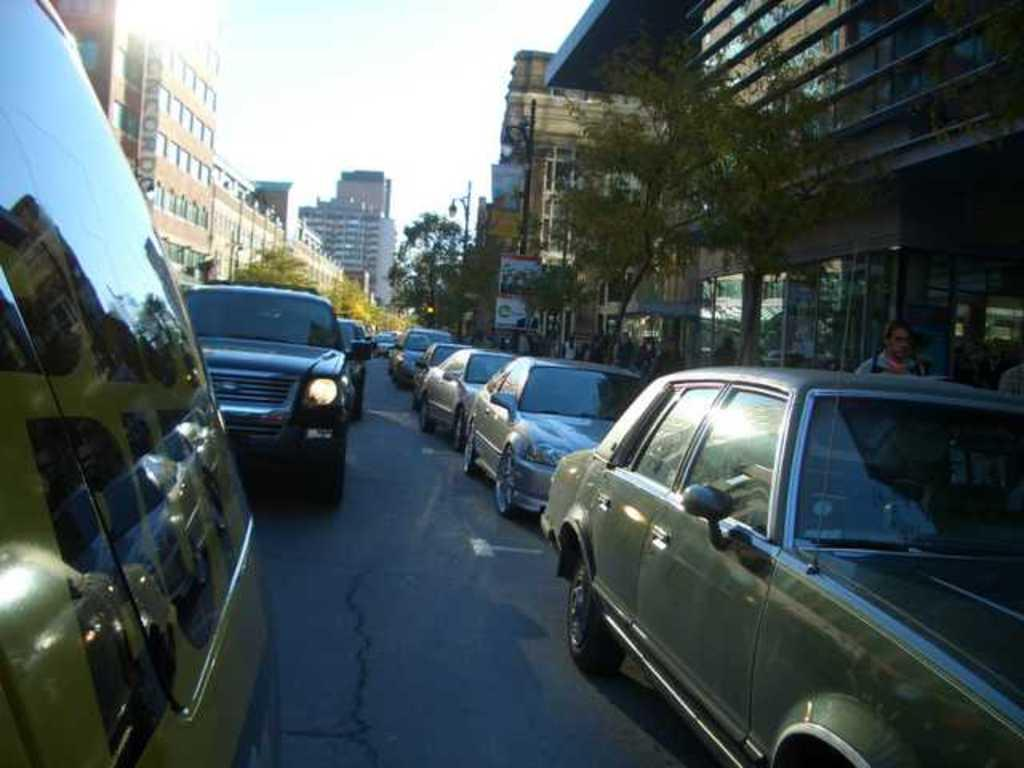What can be seen on both sides of the road in the image? There are cars on either side of the road in the image. What structures are visible behind the cars? There are buildings behind the cars in the image. What type of vegetation is in front of the buildings? There are trees in front of the buildings in the image. What part of the natural environment is visible in the image? The sky is visible above the scene in the image. How does the education system in the image help the deer? There are no references to education or deer in the image, so it is not possible to answer that question. 